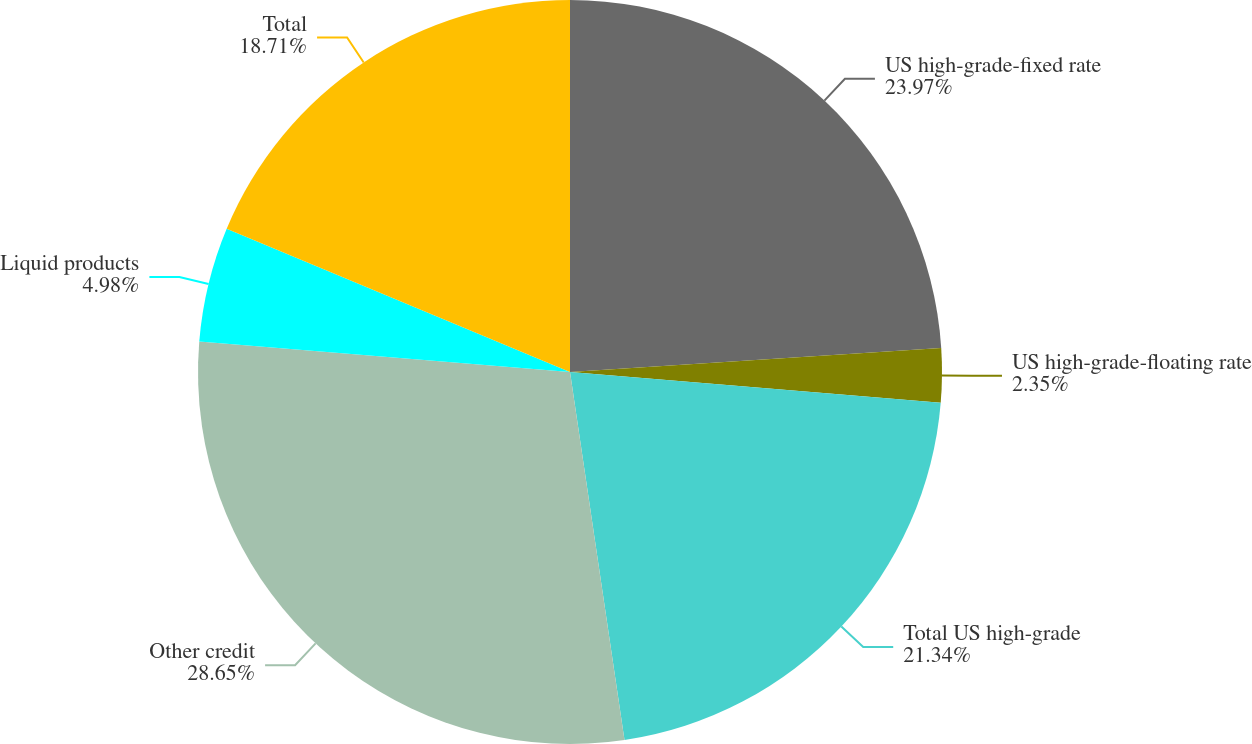Convert chart. <chart><loc_0><loc_0><loc_500><loc_500><pie_chart><fcel>US high-grade-fixed rate<fcel>US high-grade-floating rate<fcel>Total US high-grade<fcel>Other credit<fcel>Liquid products<fcel>Total<nl><fcel>23.97%<fcel>2.35%<fcel>21.34%<fcel>28.65%<fcel>4.98%<fcel>18.71%<nl></chart> 